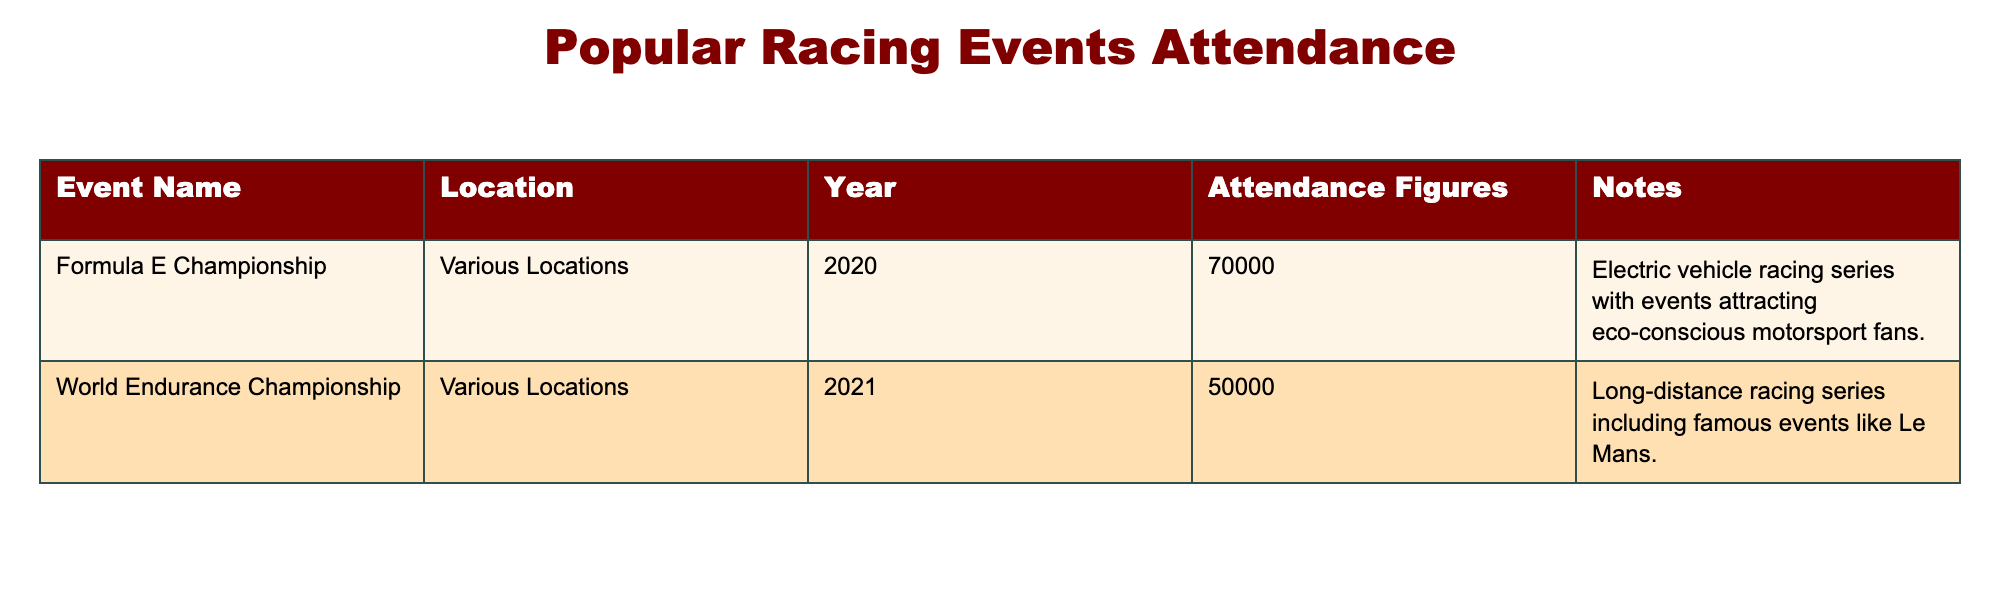What was the attendance figure for the Formula E Championship in 2020? The table indicates that the attendance figure for the Formula E Championship in 2020 is 70,000.
Answer: 70,000 Which event had a lower attendance figure, the Formula E Championship or the World Endurance Championship in 2021? The Formula E Championship had 70,000 attendees while the World Endurance Championship had 50,000 attendees. Comparing these figures, 50,000 is lower than 70,000.
Answer: World Endurance Championship What is the total attendance across both events listed in the table? To find the total attendance, we sum the attendance figures of both events: 70,000 for the Formula E Championship and 50,000 for the World Endurance Championship. The total is 70,000 + 50,000 = 120,000.
Answer: 120,000 Did the World Endurance Championship event have more participants than the Formula E Championship event in 2020? The World Endurance Championship had 50,000 attendees, and the Formula E Championship had 70,000 attendees. Since 50,000 is less than 70,000, the World Endurance Championship did not have more participants.
Answer: No What was the attendance difference between the two events? The attendance difference can be calculated by subtracting the World Endurance Championship's attendance from the Formula E Championship's attendance: 70,000 - 50,000 = 20,000. Therefore, the attendance difference is 20,000.
Answer: 20,000 Which event took place in 2021, and what was its attendance figure? The table shows that the World Endurance Championship took place in 2021, with an attendance figure of 50,000.
Answer: World Endurance Championship, 50,000 In what year did the Formula E Championship occur? The table specifies that the Formula E Championship occurred in 2020, as indicated by the year column associated with it.
Answer: 2020 Was the attendance for the Formula E Championship higher than 60,000? The attendance figure for the Formula E Championship is recorded as 70,000, which is indeed higher than 60,000.
Answer: Yes 